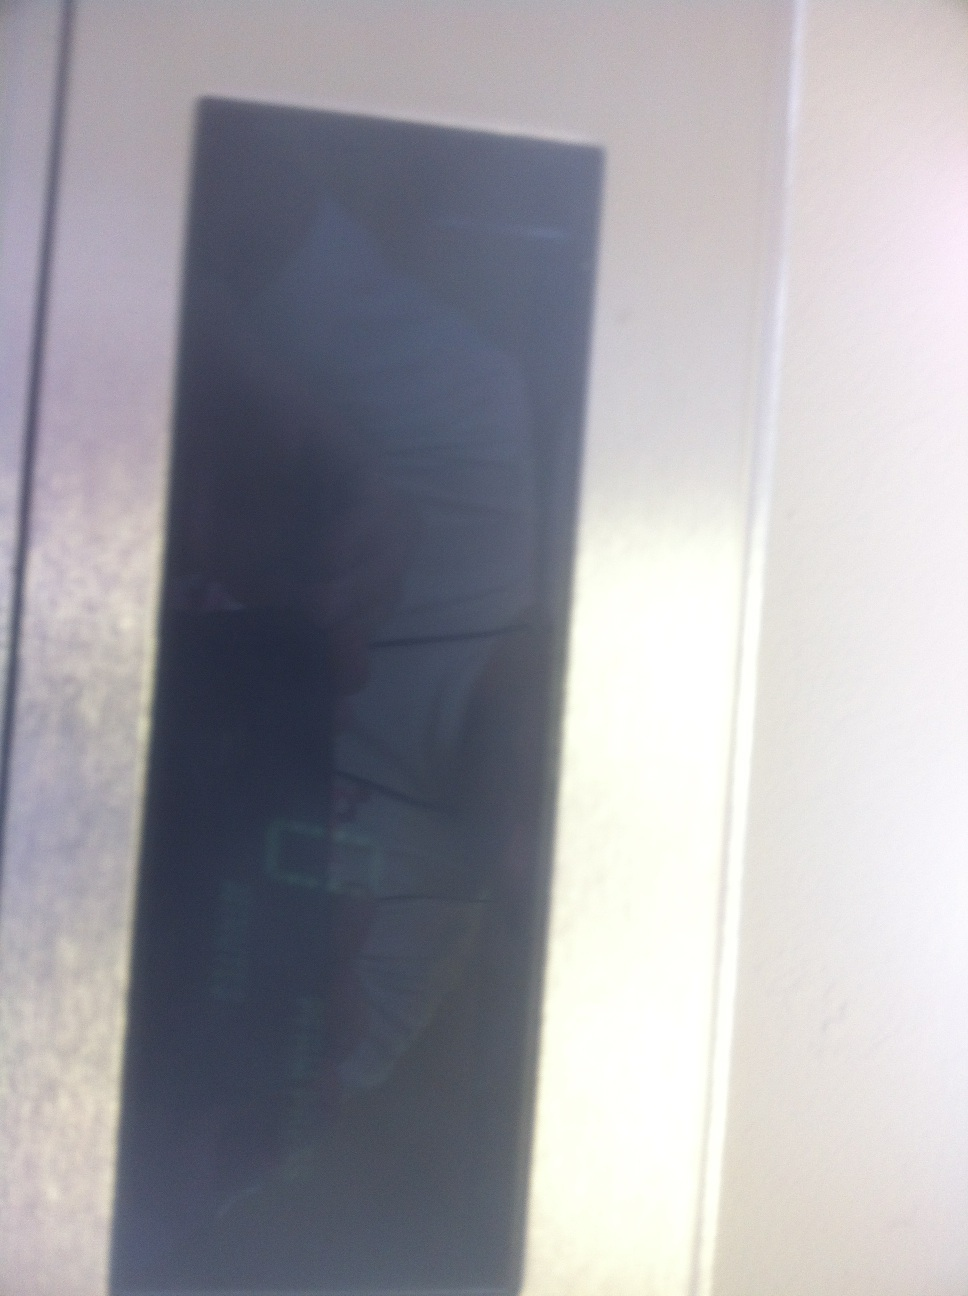Imagine this display is part of a spaceship's control panel. How does it contribute to a space mission? In the context of a spaceship, this display could serve a variety of crucial functions. It might show real-time data about the spacecraft's systems, such as fuel levels, life support status, or navigational coordinates. It could also be part of a communication array, displaying incoming and outgoing messages or alerts to the crew. Keeping this display in optimal condition would be vital to ensure the smooth operation of the spacecraft and the safety of its occupants during a space mission. 